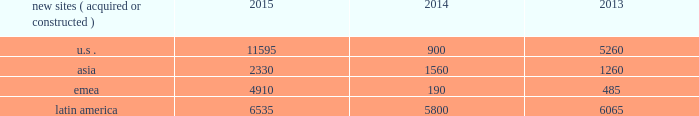The long term .
In addition , we have focused on building relationships with large multinational carriers such as airtel , telef f3nica s.a .
And vodafone group plc .
We believe that consistent carrier investments in their networks across our international markets position us to generate meaningful organic revenue growth going forward .
In emerging markets , such as ghana , india , nigeria and uganda , wireless networks tend to be significantly less advanced than those in the united states , and initial voice networks continue to be deployed in underdeveloped areas .
A majority of consumers in these markets still utilize basic wireless services , predominantly on feature phones , while advanced device penetration remains low .
In more developed urban locations within these markets , early-stage data network deployments are underway .
Carriers are focused on completing voice network build-outs while also investing in initial data networks as wireless data usage and smartphone penetration within their customer bases begin to accelerate .
In markets with rapidly evolving network technology , such as south africa and most of the countries in latin america where we do business , initial voice networks , for the most part , have already been built out , and carriers are focused on 3g network build outs , with select investments in 4g technology .
Consumers in these regions are increasingly adopting smartphones and other advanced devices , and as a result , the usage of bandwidth-intensive mobile applications is growing materially .
Recent spectrum auctions in these rapidly evolving markets have allowed incumbent carriers to accelerate their data network deployments and have also enabled new entrants to begin initial investments in data networks .
Smartphone penetration and wireless data usage in these markets are growing rapidly , which typically requires that carriers continue to invest in their networks in order to maintain and augment their quality of service .
Finally , in markets with more mature network technology , such as germany , carriers are focused on deploying 4g data networks to account for rapidly increasing wireless data usage amongst their customer base .
With higher smartphone and advanced device penetration and significantly higher per capita data usage , carrier investment in networks is focused on 4g coverage and capacity .
We believe that the network technology migration we have seen in the united states , which has led to significantly denser networks and meaningful new business commencements for us over a number of years , will ultimately be replicated in our less advanced international markets .
As a result , we expect to be able to leverage our extensive international portfolio of approximately 60190 communications sites and the relationships we have built with our carrier customers to drive sustainable , long-term growth .
We have holistic master lease agreements with certain of our tenants that provide for consistent , long-term revenue and a reduction in the likelihood of churn .
Our holistic master lease agreements build and augment strong strategic partnerships with our tenants and have significantly reduced collocation cycle times , thereby providing our tenants with the ability to rapidly and efficiently deploy equipment on our sites .
Property operations new site revenue growth .
During the year ended december 31 , 2015 , we grew our portfolio of communications real estate through the acquisition and construction of approximately 25370 sites .
In a majority of our asia , emea and latin america markets , the acquisition or construction of new sites resulted in increases in both tenant and pass- through revenues ( such as ground rent or power and fuel costs ) and expenses .
We continue to evaluate opportunities to acquire communications real estate portfolios , both domestically and internationally , to determine whether they meet our risk-adjusted hurdle rates and whether we believe we can effectively integrate them into our existing portfolio. .
Property operations expenses .
Direct operating expenses incurred by our property segments include direct site level expenses and consist primarily of ground rent and power and fuel costs , some or all of which may be passed through to our tenants , as well as property taxes , repairs and maintenance .
These segment direct operating expenses exclude all segment and corporate selling , general , administrative and development expenses , which are aggregated into one line item entitled selling , general , administrative and development expense in our consolidated statements of operations .
In general , our property segments 2019 selling , general , administrative and development expenses do not significantly increase as a result of adding incremental tenants to our legacy sites and typically increase only modestly year-over-year .
As a result , leasing additional space to new tenants on our legacy sites provides significant incremental cash flow .
We may , however , incur additional segment .
What is the total number of sites acquired and constructed during 2014? 
Computations: (((900 + 1560) + 190) + 5800)
Answer: 8450.0. 